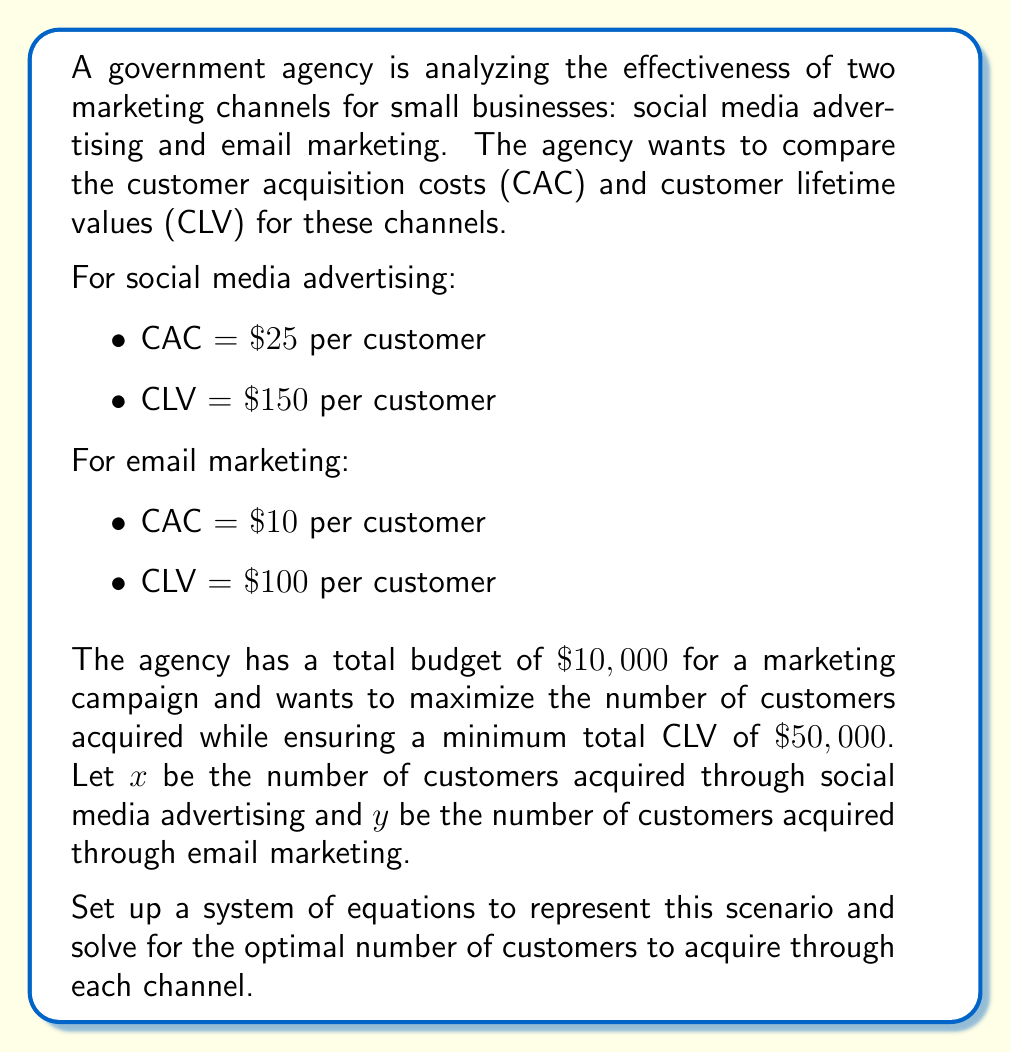Can you answer this question? To solve this problem, we need to set up a system of equations based on the given constraints and then solve it. Let's break it down step by step:

1. Budget constraint:
   The total cost of acquiring customers through both channels should not exceed the budget of $\$10,000$.
   $$25x + 10y \leq 10000$$

2. CLV constraint:
   The total CLV from both channels should be at least $\$50,000$.
   $$150x + 100y \geq 50000$$

3. Objective:
   Maximize the total number of customers acquired $(x + y)$.

Now, we have a system of linear inequalities:

$$\begin{cases}
25x + 10y \leq 10000 \\
150x + 100y \geq 50000 \\
x \geq 0, y \geq 0
\end{cases}$$

To find the optimal solution, we need to find the intersection point of these two lines that maximizes $x + y$.

4. Convert inequalities to equations:
   $$\begin{cases}
   25x + 10y = 10000 \\
   150x + 100y = 50000
   \end{cases}$$

5. Solve the system of equations:
   Multiply the first equation by 6 and the second by -1:
   $$\begin{cases}
   150x + 60y = 60000 \\
   -150x - 100y = -50000
   \end{cases}$$

   Add the equations:
   $$-40y = 10000$$
   $$y = -250$$

   Substitute y back into the first equation:
   $$25x + 10(-250) = 10000$$
   $$25x = 12500$$
   $$x = 500$$

6. Check if the solution satisfies the non-negativity constraints:
   $x = 500 \geq 0$, but $y = -250 < 0$, so this solution is not feasible.

7. Since we can't have a negative number of customers, we need to find the optimal integer solution along the budget constraint line:
   $$25x + 10y = 10000$$

8. Try different integer values for x and y that satisfy this equation and maximize $x + y$:
   $$x = 0, y = 1000$$ (Total customers: 1000)
   $$x = 100, y = 750$$ (Total customers: 850)
   $$x = 200, y = 500$$ (Total customers: 700)
   $$x = 300, y = 250$$ (Total customers: 550)
   $$x = 400, y = 0$$ (Total customers: 400)

9. Check if these solutions satisfy the CLV constraint:
   For $x = 0, y = 1000$: $150(0) + 100(1000) = 100000 \geq 50000$ (Satisfies)
   For $x = 100, y = 750$: $150(100) + 100(750) = 90000 \geq 50000$ (Satisfies)
   For $x = 200, y = 500$: $150(200) + 100(500) = 80000 \geq 50000$ (Satisfies)
   For $x = 300, y = 250$: $150(300) + 100(250) = 70000 \geq 50000$ (Satisfies)
   For $x = 400, y = 0$: $150(400) + 100(0) = 60000 \geq 50000$ (Satisfies)

Therefore, the optimal solution that maximizes the total number of customers acquired while satisfying all constraints is $x = 0$ and $y = 1000$.
Answer: The optimal solution is to acquire 0 customers through social media advertising $(x = 0)$ and 1000 customers through email marketing $(y = 1000)$. This maximizes the total number of customers acquired at 1000 while satisfying both the budget constraint and the minimum total CLV requirement. 